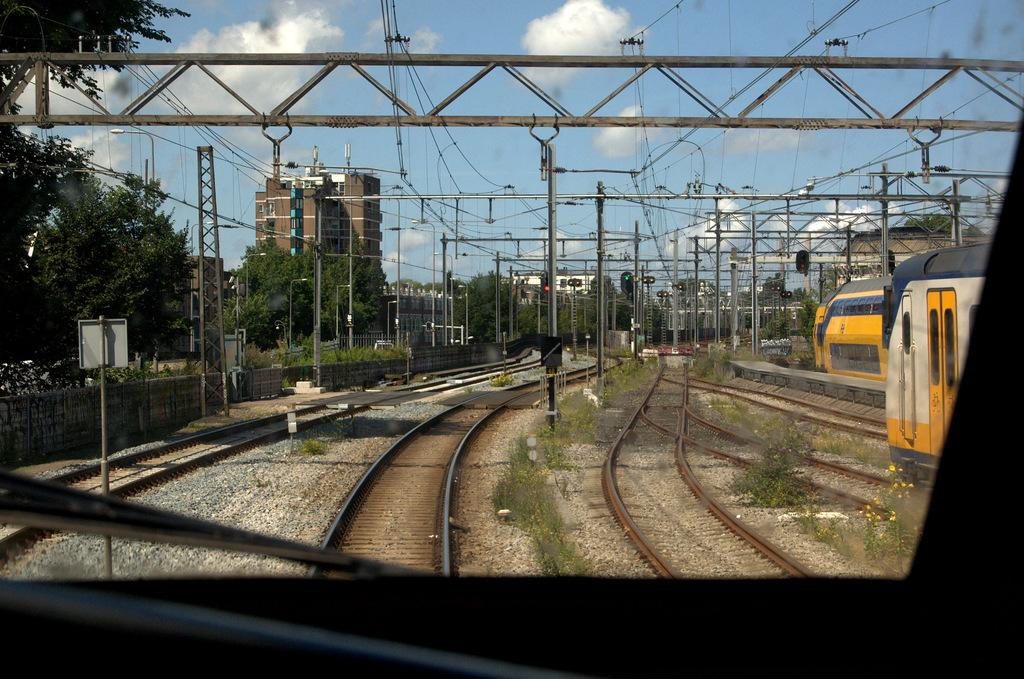What type of vehicles can be seen in the image? There are trains in the image. What is the path that the trains follow? Railway tracks are present in the image. What structures are supporting the electrical wires in the image? There are poles in the image. What devices are used to regulate traffic in the image? Traffic signals are visible in the image. What tall structure can be seen in the image? There is a tower in the image. What type of barrier is present in the image? There is a wall in the image. What type of vegetation is present in the image? Plants and trees are visible in the image. What type of buildings can be seen in the image? There are buildings in the image. What is visible in the background of the image? The sky is visible in the background of the image. What atmospheric feature can be seen in the sky? Clouds are present in the sky. Where is the needle located in the image? There is no needle present in the image. What is the boy doing in the image? There is no boy present in the image. What type of planet is visible in the image? The image does not depict any planets, including Earth. 